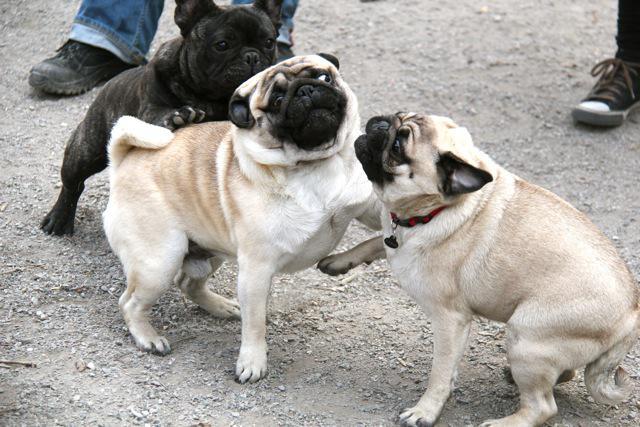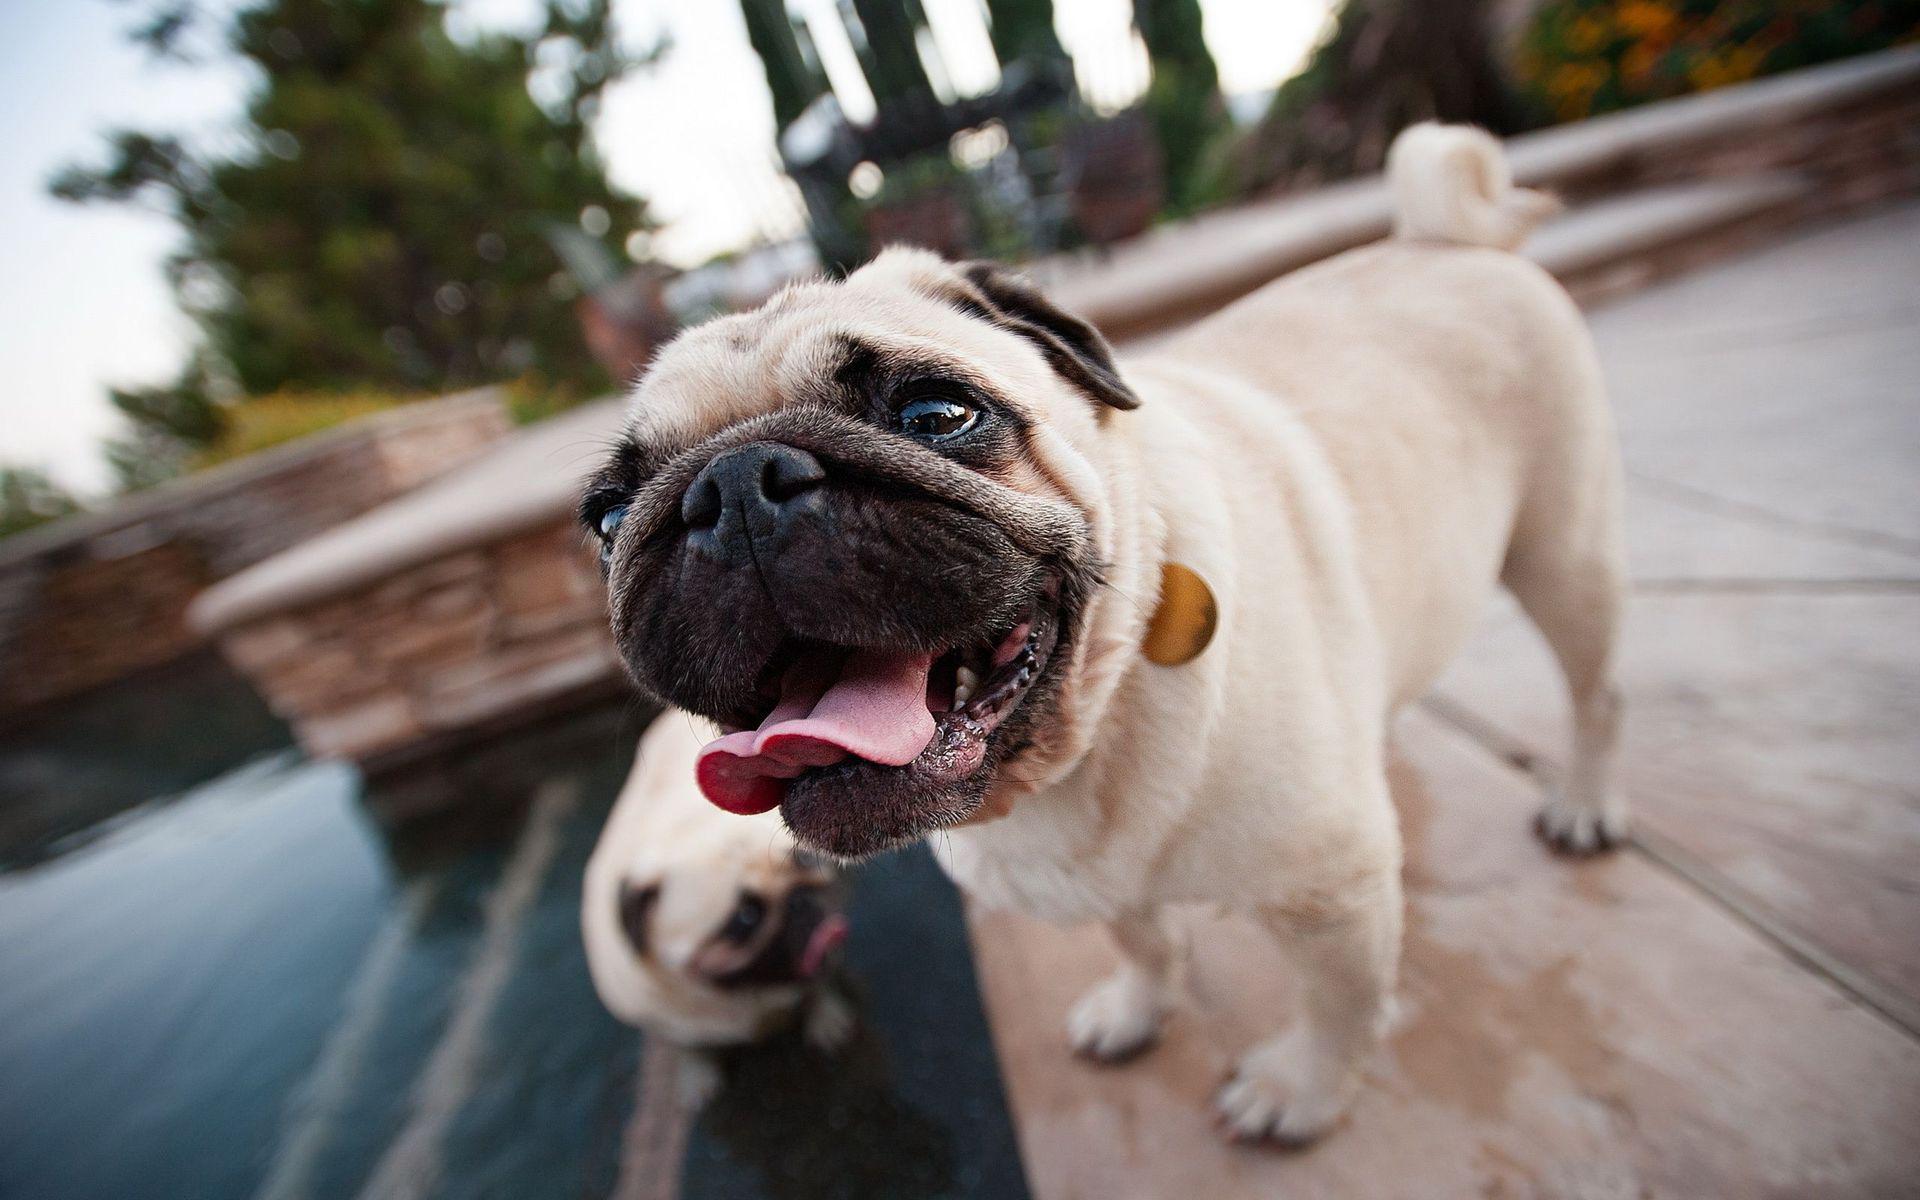The first image is the image on the left, the second image is the image on the right. Considering the images on both sides, is "One of the pugs shown is black, and the rest are light tan with dark faces." valid? Answer yes or no. Yes. 